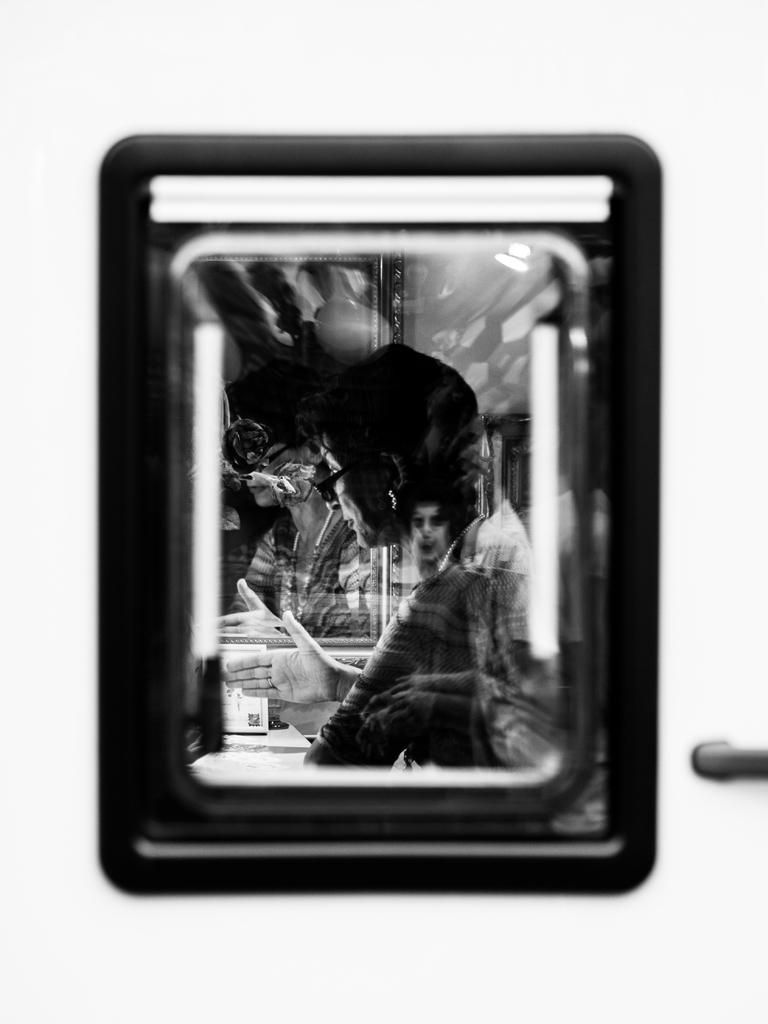What is the color scheme of the image? The image is black and white. What object can be seen in the image? There is a mirror in the image. Who or what is visible in the mirror? There are persons visible in the mirror. How would you describe the clarity of the image? The image appears blurred. What type of hair can be seen on the wren in the image? There is no wren present in the image, so it is not possible to determine the type of hair on a wren. 